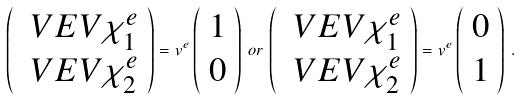<formula> <loc_0><loc_0><loc_500><loc_500>\left ( \begin{array} { c } \ V E V { \chi _ { 1 } ^ { e } } \\ \ V E V { \chi _ { 2 } ^ { e } } \end{array} \right ) = v ^ { e } \left ( \begin{array} { c } 1 \\ 0 \end{array} \right ) \, o r \, \left ( \begin{array} { c } \ V E V { \chi _ { 1 } ^ { e } } \\ \ V E V { \chi _ { 2 } ^ { e } } \end{array} \right ) = v ^ { e } \left ( \begin{array} { c } 0 \\ 1 \end{array} \right ) \, .</formula> 